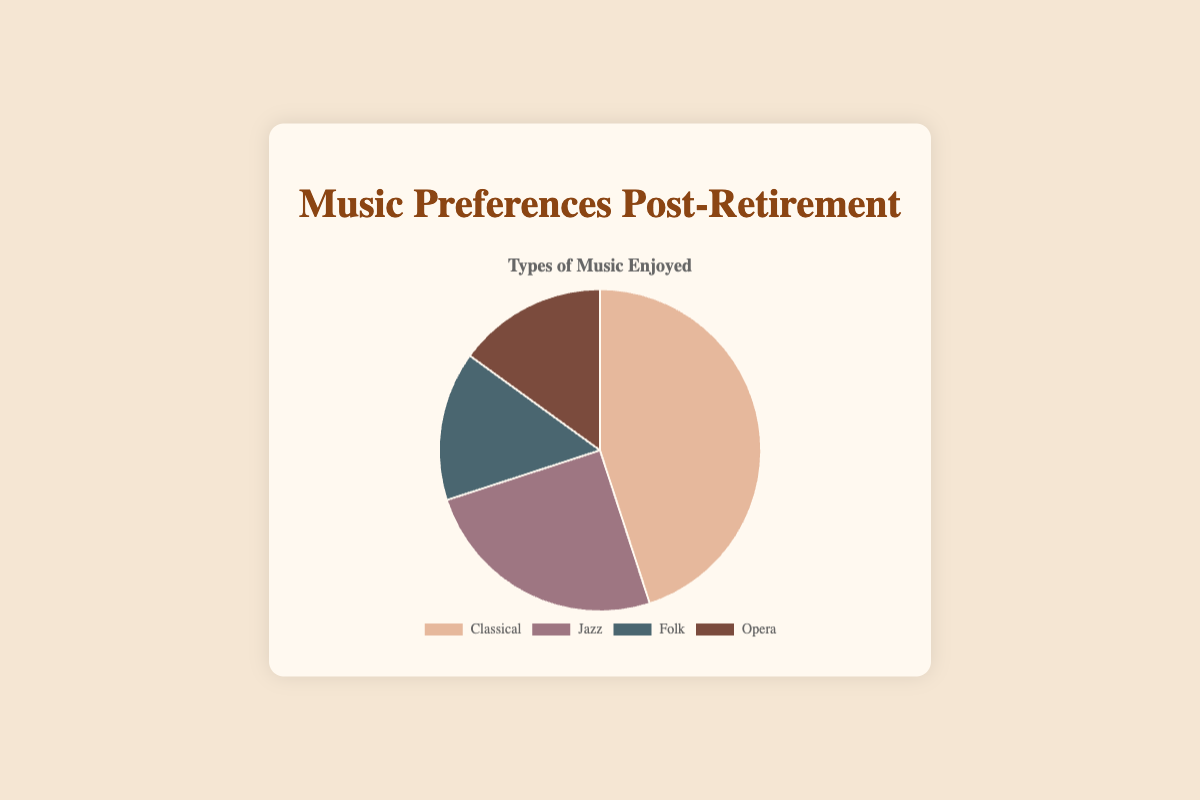Which type of music is enjoyed the most post-retirement? The pie chart shows percentages for different types of music enjoyed: Classical (45%), Jazz (25%), Folk (15%), and Opera (15%). By comparing these values, Classical is the highest.
Answer: Classical What types of music are equally enjoyed and what percentage do they share? The percentages for Folk and Opera are both 15%.
Answer: Folk and Opera, 15% Which music type is enjoyed more: Jazz or Folk? Jazz has a percentage of 25% while Folk has 15%. Therefore, Jazz is enjoyed more than Folk.
Answer: Jazz What is the total percentage for Classical and Jazz? Classical is 45% and Jazz is 25%. Summing these up gives 45% + 25% = 70%.
Answer: 70% What is the combined percentage of Folk and Opera, and how does it compare to the percentage of Classical music? Folk is 15% and Opera is 15%. Combined, they are 15% + 15% = 30%. Classical music alone has 45%. So, Classical is 15% more than Folk and Opera combined.
Answer: 30%, Classical is 15% more What percentage of the chart is not occupied by Classical music? Classical music takes up 45%. The remainder is 100% - 45% = 55%.
Answer: 55% How does the enjoyment of Jazz compare to the combined enjoyment of Folk and Opera? Jazz is 25%. Folk and Opera combined are 15% + 15% = 30%. Therefore, Jazz is 5% less than the combined percentage of Folk and Opera.
Answer: Jazz is 5% less Which section is represented by the darkest color on the chart? The pie chart uses different shades for each type: Classical, Jazz, Folk, Opera. Without specific color codes, it's assumed Opera has the darkest color based on typical visual representations.
Answer: Opera If you were to remove the Classical section, what percentage of the chart would the other music types represent together? Classical is 45%, so the remaining types (Jazz, Folk, Opera) represent 100% - 45% = 55%.
Answer: 55% 